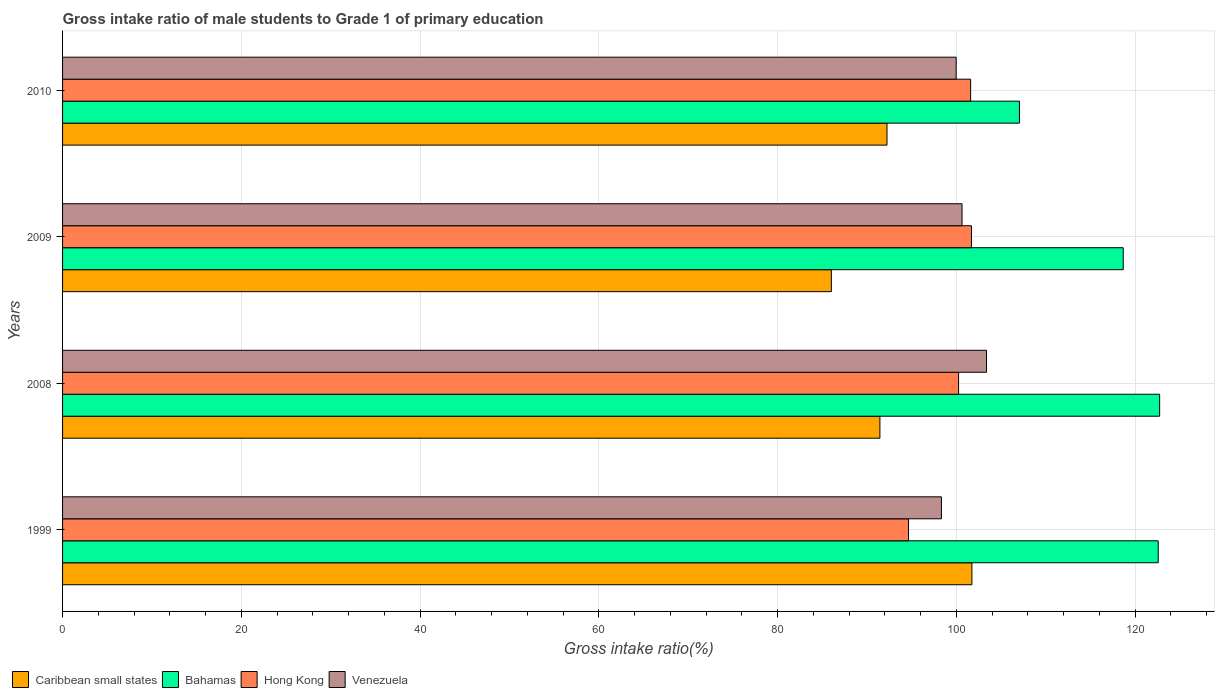How many different coloured bars are there?
Your answer should be compact. 4. How many groups of bars are there?
Make the answer very short. 4. Are the number of bars on each tick of the Y-axis equal?
Your answer should be compact. Yes. How many bars are there on the 3rd tick from the top?
Ensure brevity in your answer.  4. How many bars are there on the 3rd tick from the bottom?
Your response must be concise. 4. What is the label of the 4th group of bars from the top?
Make the answer very short. 1999. What is the gross intake ratio in Caribbean small states in 2009?
Make the answer very short. 86. Across all years, what is the maximum gross intake ratio in Caribbean small states?
Ensure brevity in your answer.  101.73. Across all years, what is the minimum gross intake ratio in Bahamas?
Your answer should be very brief. 107.05. In which year was the gross intake ratio in Bahamas maximum?
Offer a very short reply. 2008. What is the total gross intake ratio in Hong Kong in the graph?
Provide a short and direct response. 398.14. What is the difference between the gross intake ratio in Venezuela in 1999 and that in 2009?
Offer a very short reply. -2.31. What is the difference between the gross intake ratio in Caribbean small states in 2009 and the gross intake ratio in Hong Kong in 2008?
Provide a short and direct response. -14.23. What is the average gross intake ratio in Caribbean small states per year?
Offer a terse response. 92.85. In the year 2008, what is the difference between the gross intake ratio in Bahamas and gross intake ratio in Venezuela?
Make the answer very short. 19.37. In how many years, is the gross intake ratio in Caribbean small states greater than 116 %?
Offer a very short reply. 0. What is the ratio of the gross intake ratio in Venezuela in 1999 to that in 2010?
Your answer should be very brief. 0.98. Is the gross intake ratio in Caribbean small states in 2008 less than that in 2010?
Offer a terse response. Yes. Is the difference between the gross intake ratio in Bahamas in 2009 and 2010 greater than the difference between the gross intake ratio in Venezuela in 2009 and 2010?
Your response must be concise. Yes. What is the difference between the highest and the second highest gross intake ratio in Bahamas?
Offer a very short reply. 0.16. What is the difference between the highest and the lowest gross intake ratio in Bahamas?
Provide a succinct answer. 15.68. In how many years, is the gross intake ratio in Hong Kong greater than the average gross intake ratio in Hong Kong taken over all years?
Your answer should be very brief. 3. Is the sum of the gross intake ratio in Venezuela in 1999 and 2010 greater than the maximum gross intake ratio in Caribbean small states across all years?
Keep it short and to the point. Yes. Is it the case that in every year, the sum of the gross intake ratio in Bahamas and gross intake ratio in Caribbean small states is greater than the sum of gross intake ratio in Hong Kong and gross intake ratio in Venezuela?
Make the answer very short. No. What does the 1st bar from the top in 2008 represents?
Keep it short and to the point. Venezuela. What does the 3rd bar from the bottom in 1999 represents?
Offer a very short reply. Hong Kong. How many bars are there?
Offer a very short reply. 16. Does the graph contain any zero values?
Provide a succinct answer. No. Where does the legend appear in the graph?
Your response must be concise. Bottom left. What is the title of the graph?
Provide a short and direct response. Gross intake ratio of male students to Grade 1 of primary education. Does "Bosnia and Herzegovina" appear as one of the legend labels in the graph?
Make the answer very short. No. What is the label or title of the X-axis?
Provide a succinct answer. Gross intake ratio(%). What is the Gross intake ratio(%) of Caribbean small states in 1999?
Provide a succinct answer. 101.73. What is the Gross intake ratio(%) in Bahamas in 1999?
Your answer should be compact. 122.57. What is the Gross intake ratio(%) in Hong Kong in 1999?
Provide a short and direct response. 94.64. What is the Gross intake ratio(%) in Venezuela in 1999?
Give a very brief answer. 98.32. What is the Gross intake ratio(%) of Caribbean small states in 2008?
Provide a succinct answer. 91.44. What is the Gross intake ratio(%) in Bahamas in 2008?
Ensure brevity in your answer.  122.73. What is the Gross intake ratio(%) in Hong Kong in 2008?
Your response must be concise. 100.24. What is the Gross intake ratio(%) in Venezuela in 2008?
Offer a very short reply. 103.36. What is the Gross intake ratio(%) in Caribbean small states in 2009?
Keep it short and to the point. 86. What is the Gross intake ratio(%) in Bahamas in 2009?
Offer a very short reply. 118.66. What is the Gross intake ratio(%) of Hong Kong in 2009?
Your response must be concise. 101.68. What is the Gross intake ratio(%) in Venezuela in 2009?
Offer a terse response. 100.62. What is the Gross intake ratio(%) of Caribbean small states in 2010?
Offer a terse response. 92.23. What is the Gross intake ratio(%) in Bahamas in 2010?
Offer a very short reply. 107.05. What is the Gross intake ratio(%) of Hong Kong in 2010?
Your answer should be compact. 101.59. What is the Gross intake ratio(%) of Venezuela in 2010?
Offer a terse response. 99.97. Across all years, what is the maximum Gross intake ratio(%) in Caribbean small states?
Provide a succinct answer. 101.73. Across all years, what is the maximum Gross intake ratio(%) of Bahamas?
Your answer should be compact. 122.73. Across all years, what is the maximum Gross intake ratio(%) of Hong Kong?
Provide a succinct answer. 101.68. Across all years, what is the maximum Gross intake ratio(%) in Venezuela?
Ensure brevity in your answer.  103.36. Across all years, what is the minimum Gross intake ratio(%) of Caribbean small states?
Offer a very short reply. 86. Across all years, what is the minimum Gross intake ratio(%) in Bahamas?
Your response must be concise. 107.05. Across all years, what is the minimum Gross intake ratio(%) of Hong Kong?
Your answer should be very brief. 94.64. Across all years, what is the minimum Gross intake ratio(%) in Venezuela?
Your answer should be compact. 98.32. What is the total Gross intake ratio(%) in Caribbean small states in the graph?
Your answer should be compact. 371.4. What is the total Gross intake ratio(%) in Bahamas in the graph?
Give a very brief answer. 471.01. What is the total Gross intake ratio(%) of Hong Kong in the graph?
Keep it short and to the point. 398.14. What is the total Gross intake ratio(%) in Venezuela in the graph?
Your answer should be very brief. 402.28. What is the difference between the Gross intake ratio(%) of Caribbean small states in 1999 and that in 2008?
Keep it short and to the point. 10.29. What is the difference between the Gross intake ratio(%) in Bahamas in 1999 and that in 2008?
Your response must be concise. -0.16. What is the difference between the Gross intake ratio(%) in Hong Kong in 1999 and that in 2008?
Ensure brevity in your answer.  -5.6. What is the difference between the Gross intake ratio(%) in Venezuela in 1999 and that in 2008?
Your answer should be compact. -5.04. What is the difference between the Gross intake ratio(%) of Caribbean small states in 1999 and that in 2009?
Offer a terse response. 15.72. What is the difference between the Gross intake ratio(%) of Bahamas in 1999 and that in 2009?
Ensure brevity in your answer.  3.91. What is the difference between the Gross intake ratio(%) in Hong Kong in 1999 and that in 2009?
Give a very brief answer. -7.04. What is the difference between the Gross intake ratio(%) in Venezuela in 1999 and that in 2009?
Give a very brief answer. -2.31. What is the difference between the Gross intake ratio(%) of Caribbean small states in 1999 and that in 2010?
Your response must be concise. 9.5. What is the difference between the Gross intake ratio(%) of Bahamas in 1999 and that in 2010?
Ensure brevity in your answer.  15.52. What is the difference between the Gross intake ratio(%) in Hong Kong in 1999 and that in 2010?
Make the answer very short. -6.95. What is the difference between the Gross intake ratio(%) in Venezuela in 1999 and that in 2010?
Ensure brevity in your answer.  -1.65. What is the difference between the Gross intake ratio(%) of Caribbean small states in 2008 and that in 2009?
Provide a short and direct response. 5.43. What is the difference between the Gross intake ratio(%) of Bahamas in 2008 and that in 2009?
Keep it short and to the point. 4.07. What is the difference between the Gross intake ratio(%) in Hong Kong in 2008 and that in 2009?
Your answer should be compact. -1.44. What is the difference between the Gross intake ratio(%) in Venezuela in 2008 and that in 2009?
Make the answer very short. 2.74. What is the difference between the Gross intake ratio(%) in Caribbean small states in 2008 and that in 2010?
Your answer should be compact. -0.79. What is the difference between the Gross intake ratio(%) of Bahamas in 2008 and that in 2010?
Ensure brevity in your answer.  15.68. What is the difference between the Gross intake ratio(%) in Hong Kong in 2008 and that in 2010?
Provide a succinct answer. -1.35. What is the difference between the Gross intake ratio(%) in Venezuela in 2008 and that in 2010?
Provide a succinct answer. 3.39. What is the difference between the Gross intake ratio(%) in Caribbean small states in 2009 and that in 2010?
Offer a terse response. -6.23. What is the difference between the Gross intake ratio(%) of Bahamas in 2009 and that in 2010?
Keep it short and to the point. 11.61. What is the difference between the Gross intake ratio(%) of Hong Kong in 2009 and that in 2010?
Your answer should be very brief. 0.09. What is the difference between the Gross intake ratio(%) in Venezuela in 2009 and that in 2010?
Keep it short and to the point. 0.66. What is the difference between the Gross intake ratio(%) of Caribbean small states in 1999 and the Gross intake ratio(%) of Bahamas in 2008?
Provide a short and direct response. -21. What is the difference between the Gross intake ratio(%) of Caribbean small states in 1999 and the Gross intake ratio(%) of Hong Kong in 2008?
Provide a succinct answer. 1.49. What is the difference between the Gross intake ratio(%) of Caribbean small states in 1999 and the Gross intake ratio(%) of Venezuela in 2008?
Ensure brevity in your answer.  -1.63. What is the difference between the Gross intake ratio(%) of Bahamas in 1999 and the Gross intake ratio(%) of Hong Kong in 2008?
Offer a terse response. 22.33. What is the difference between the Gross intake ratio(%) in Bahamas in 1999 and the Gross intake ratio(%) in Venezuela in 2008?
Your response must be concise. 19.21. What is the difference between the Gross intake ratio(%) in Hong Kong in 1999 and the Gross intake ratio(%) in Venezuela in 2008?
Provide a succinct answer. -8.73. What is the difference between the Gross intake ratio(%) of Caribbean small states in 1999 and the Gross intake ratio(%) of Bahamas in 2009?
Give a very brief answer. -16.93. What is the difference between the Gross intake ratio(%) in Caribbean small states in 1999 and the Gross intake ratio(%) in Hong Kong in 2009?
Provide a succinct answer. 0.05. What is the difference between the Gross intake ratio(%) in Caribbean small states in 1999 and the Gross intake ratio(%) in Venezuela in 2009?
Offer a very short reply. 1.1. What is the difference between the Gross intake ratio(%) in Bahamas in 1999 and the Gross intake ratio(%) in Hong Kong in 2009?
Ensure brevity in your answer.  20.89. What is the difference between the Gross intake ratio(%) of Bahamas in 1999 and the Gross intake ratio(%) of Venezuela in 2009?
Your answer should be very brief. 21.95. What is the difference between the Gross intake ratio(%) in Hong Kong in 1999 and the Gross intake ratio(%) in Venezuela in 2009?
Keep it short and to the point. -5.99. What is the difference between the Gross intake ratio(%) of Caribbean small states in 1999 and the Gross intake ratio(%) of Bahamas in 2010?
Make the answer very short. -5.32. What is the difference between the Gross intake ratio(%) of Caribbean small states in 1999 and the Gross intake ratio(%) of Hong Kong in 2010?
Your answer should be very brief. 0.14. What is the difference between the Gross intake ratio(%) of Caribbean small states in 1999 and the Gross intake ratio(%) of Venezuela in 2010?
Give a very brief answer. 1.76. What is the difference between the Gross intake ratio(%) in Bahamas in 1999 and the Gross intake ratio(%) in Hong Kong in 2010?
Provide a short and direct response. 20.98. What is the difference between the Gross intake ratio(%) in Bahamas in 1999 and the Gross intake ratio(%) in Venezuela in 2010?
Your answer should be compact. 22.6. What is the difference between the Gross intake ratio(%) of Hong Kong in 1999 and the Gross intake ratio(%) of Venezuela in 2010?
Keep it short and to the point. -5.33. What is the difference between the Gross intake ratio(%) in Caribbean small states in 2008 and the Gross intake ratio(%) in Bahamas in 2009?
Provide a succinct answer. -27.22. What is the difference between the Gross intake ratio(%) of Caribbean small states in 2008 and the Gross intake ratio(%) of Hong Kong in 2009?
Your answer should be very brief. -10.24. What is the difference between the Gross intake ratio(%) in Caribbean small states in 2008 and the Gross intake ratio(%) in Venezuela in 2009?
Offer a very short reply. -9.19. What is the difference between the Gross intake ratio(%) in Bahamas in 2008 and the Gross intake ratio(%) in Hong Kong in 2009?
Your answer should be very brief. 21.05. What is the difference between the Gross intake ratio(%) in Bahamas in 2008 and the Gross intake ratio(%) in Venezuela in 2009?
Provide a short and direct response. 22.11. What is the difference between the Gross intake ratio(%) in Hong Kong in 2008 and the Gross intake ratio(%) in Venezuela in 2009?
Ensure brevity in your answer.  -0.39. What is the difference between the Gross intake ratio(%) of Caribbean small states in 2008 and the Gross intake ratio(%) of Bahamas in 2010?
Your response must be concise. -15.61. What is the difference between the Gross intake ratio(%) of Caribbean small states in 2008 and the Gross intake ratio(%) of Hong Kong in 2010?
Your answer should be compact. -10.15. What is the difference between the Gross intake ratio(%) in Caribbean small states in 2008 and the Gross intake ratio(%) in Venezuela in 2010?
Offer a very short reply. -8.53. What is the difference between the Gross intake ratio(%) of Bahamas in 2008 and the Gross intake ratio(%) of Hong Kong in 2010?
Provide a short and direct response. 21.14. What is the difference between the Gross intake ratio(%) of Bahamas in 2008 and the Gross intake ratio(%) of Venezuela in 2010?
Ensure brevity in your answer.  22.76. What is the difference between the Gross intake ratio(%) of Hong Kong in 2008 and the Gross intake ratio(%) of Venezuela in 2010?
Make the answer very short. 0.27. What is the difference between the Gross intake ratio(%) in Caribbean small states in 2009 and the Gross intake ratio(%) in Bahamas in 2010?
Offer a terse response. -21.04. What is the difference between the Gross intake ratio(%) of Caribbean small states in 2009 and the Gross intake ratio(%) of Hong Kong in 2010?
Your response must be concise. -15.58. What is the difference between the Gross intake ratio(%) in Caribbean small states in 2009 and the Gross intake ratio(%) in Venezuela in 2010?
Your answer should be compact. -13.96. What is the difference between the Gross intake ratio(%) in Bahamas in 2009 and the Gross intake ratio(%) in Hong Kong in 2010?
Offer a very short reply. 17.07. What is the difference between the Gross intake ratio(%) in Bahamas in 2009 and the Gross intake ratio(%) in Venezuela in 2010?
Your answer should be compact. 18.69. What is the difference between the Gross intake ratio(%) in Hong Kong in 2009 and the Gross intake ratio(%) in Venezuela in 2010?
Offer a very short reply. 1.71. What is the average Gross intake ratio(%) of Caribbean small states per year?
Your answer should be very brief. 92.85. What is the average Gross intake ratio(%) of Bahamas per year?
Ensure brevity in your answer.  117.75. What is the average Gross intake ratio(%) in Hong Kong per year?
Offer a very short reply. 99.53. What is the average Gross intake ratio(%) of Venezuela per year?
Your answer should be very brief. 100.57. In the year 1999, what is the difference between the Gross intake ratio(%) in Caribbean small states and Gross intake ratio(%) in Bahamas?
Give a very brief answer. -20.84. In the year 1999, what is the difference between the Gross intake ratio(%) of Caribbean small states and Gross intake ratio(%) of Hong Kong?
Provide a succinct answer. 7.09. In the year 1999, what is the difference between the Gross intake ratio(%) in Caribbean small states and Gross intake ratio(%) in Venezuela?
Ensure brevity in your answer.  3.41. In the year 1999, what is the difference between the Gross intake ratio(%) in Bahamas and Gross intake ratio(%) in Hong Kong?
Provide a short and direct response. 27.93. In the year 1999, what is the difference between the Gross intake ratio(%) in Bahamas and Gross intake ratio(%) in Venezuela?
Provide a succinct answer. 24.25. In the year 1999, what is the difference between the Gross intake ratio(%) in Hong Kong and Gross intake ratio(%) in Venezuela?
Offer a very short reply. -3.68. In the year 2008, what is the difference between the Gross intake ratio(%) in Caribbean small states and Gross intake ratio(%) in Bahamas?
Give a very brief answer. -31.29. In the year 2008, what is the difference between the Gross intake ratio(%) in Caribbean small states and Gross intake ratio(%) in Hong Kong?
Your response must be concise. -8.8. In the year 2008, what is the difference between the Gross intake ratio(%) in Caribbean small states and Gross intake ratio(%) in Venezuela?
Give a very brief answer. -11.93. In the year 2008, what is the difference between the Gross intake ratio(%) of Bahamas and Gross intake ratio(%) of Hong Kong?
Your answer should be very brief. 22.49. In the year 2008, what is the difference between the Gross intake ratio(%) in Bahamas and Gross intake ratio(%) in Venezuela?
Your answer should be compact. 19.37. In the year 2008, what is the difference between the Gross intake ratio(%) of Hong Kong and Gross intake ratio(%) of Venezuela?
Provide a short and direct response. -3.12. In the year 2009, what is the difference between the Gross intake ratio(%) of Caribbean small states and Gross intake ratio(%) of Bahamas?
Your answer should be very brief. -32.65. In the year 2009, what is the difference between the Gross intake ratio(%) of Caribbean small states and Gross intake ratio(%) of Hong Kong?
Give a very brief answer. -15.67. In the year 2009, what is the difference between the Gross intake ratio(%) of Caribbean small states and Gross intake ratio(%) of Venezuela?
Offer a very short reply. -14.62. In the year 2009, what is the difference between the Gross intake ratio(%) of Bahamas and Gross intake ratio(%) of Hong Kong?
Your answer should be compact. 16.98. In the year 2009, what is the difference between the Gross intake ratio(%) of Bahamas and Gross intake ratio(%) of Venezuela?
Make the answer very short. 18.03. In the year 2009, what is the difference between the Gross intake ratio(%) in Hong Kong and Gross intake ratio(%) in Venezuela?
Ensure brevity in your answer.  1.05. In the year 2010, what is the difference between the Gross intake ratio(%) of Caribbean small states and Gross intake ratio(%) of Bahamas?
Provide a short and direct response. -14.82. In the year 2010, what is the difference between the Gross intake ratio(%) of Caribbean small states and Gross intake ratio(%) of Hong Kong?
Provide a short and direct response. -9.36. In the year 2010, what is the difference between the Gross intake ratio(%) of Caribbean small states and Gross intake ratio(%) of Venezuela?
Make the answer very short. -7.74. In the year 2010, what is the difference between the Gross intake ratio(%) of Bahamas and Gross intake ratio(%) of Hong Kong?
Provide a short and direct response. 5.46. In the year 2010, what is the difference between the Gross intake ratio(%) in Bahamas and Gross intake ratio(%) in Venezuela?
Give a very brief answer. 7.08. In the year 2010, what is the difference between the Gross intake ratio(%) in Hong Kong and Gross intake ratio(%) in Venezuela?
Make the answer very short. 1.62. What is the ratio of the Gross intake ratio(%) of Caribbean small states in 1999 to that in 2008?
Ensure brevity in your answer.  1.11. What is the ratio of the Gross intake ratio(%) of Bahamas in 1999 to that in 2008?
Ensure brevity in your answer.  1. What is the ratio of the Gross intake ratio(%) in Hong Kong in 1999 to that in 2008?
Your answer should be compact. 0.94. What is the ratio of the Gross intake ratio(%) in Venezuela in 1999 to that in 2008?
Provide a short and direct response. 0.95. What is the ratio of the Gross intake ratio(%) in Caribbean small states in 1999 to that in 2009?
Offer a terse response. 1.18. What is the ratio of the Gross intake ratio(%) of Bahamas in 1999 to that in 2009?
Provide a succinct answer. 1.03. What is the ratio of the Gross intake ratio(%) of Hong Kong in 1999 to that in 2009?
Give a very brief answer. 0.93. What is the ratio of the Gross intake ratio(%) in Venezuela in 1999 to that in 2009?
Keep it short and to the point. 0.98. What is the ratio of the Gross intake ratio(%) in Caribbean small states in 1999 to that in 2010?
Keep it short and to the point. 1.1. What is the ratio of the Gross intake ratio(%) in Bahamas in 1999 to that in 2010?
Make the answer very short. 1.15. What is the ratio of the Gross intake ratio(%) in Hong Kong in 1999 to that in 2010?
Provide a succinct answer. 0.93. What is the ratio of the Gross intake ratio(%) in Venezuela in 1999 to that in 2010?
Your response must be concise. 0.98. What is the ratio of the Gross intake ratio(%) of Caribbean small states in 2008 to that in 2009?
Offer a very short reply. 1.06. What is the ratio of the Gross intake ratio(%) in Bahamas in 2008 to that in 2009?
Your answer should be very brief. 1.03. What is the ratio of the Gross intake ratio(%) in Hong Kong in 2008 to that in 2009?
Your answer should be very brief. 0.99. What is the ratio of the Gross intake ratio(%) of Venezuela in 2008 to that in 2009?
Offer a terse response. 1.03. What is the ratio of the Gross intake ratio(%) in Bahamas in 2008 to that in 2010?
Keep it short and to the point. 1.15. What is the ratio of the Gross intake ratio(%) of Hong Kong in 2008 to that in 2010?
Give a very brief answer. 0.99. What is the ratio of the Gross intake ratio(%) in Venezuela in 2008 to that in 2010?
Provide a short and direct response. 1.03. What is the ratio of the Gross intake ratio(%) of Caribbean small states in 2009 to that in 2010?
Provide a succinct answer. 0.93. What is the ratio of the Gross intake ratio(%) of Bahamas in 2009 to that in 2010?
Provide a succinct answer. 1.11. What is the ratio of the Gross intake ratio(%) of Hong Kong in 2009 to that in 2010?
Your response must be concise. 1. What is the ratio of the Gross intake ratio(%) in Venezuela in 2009 to that in 2010?
Your answer should be compact. 1.01. What is the difference between the highest and the second highest Gross intake ratio(%) in Caribbean small states?
Your answer should be very brief. 9.5. What is the difference between the highest and the second highest Gross intake ratio(%) of Bahamas?
Ensure brevity in your answer.  0.16. What is the difference between the highest and the second highest Gross intake ratio(%) of Hong Kong?
Provide a short and direct response. 0.09. What is the difference between the highest and the second highest Gross intake ratio(%) in Venezuela?
Keep it short and to the point. 2.74. What is the difference between the highest and the lowest Gross intake ratio(%) in Caribbean small states?
Make the answer very short. 15.72. What is the difference between the highest and the lowest Gross intake ratio(%) of Bahamas?
Offer a very short reply. 15.68. What is the difference between the highest and the lowest Gross intake ratio(%) of Hong Kong?
Your answer should be compact. 7.04. What is the difference between the highest and the lowest Gross intake ratio(%) in Venezuela?
Keep it short and to the point. 5.04. 